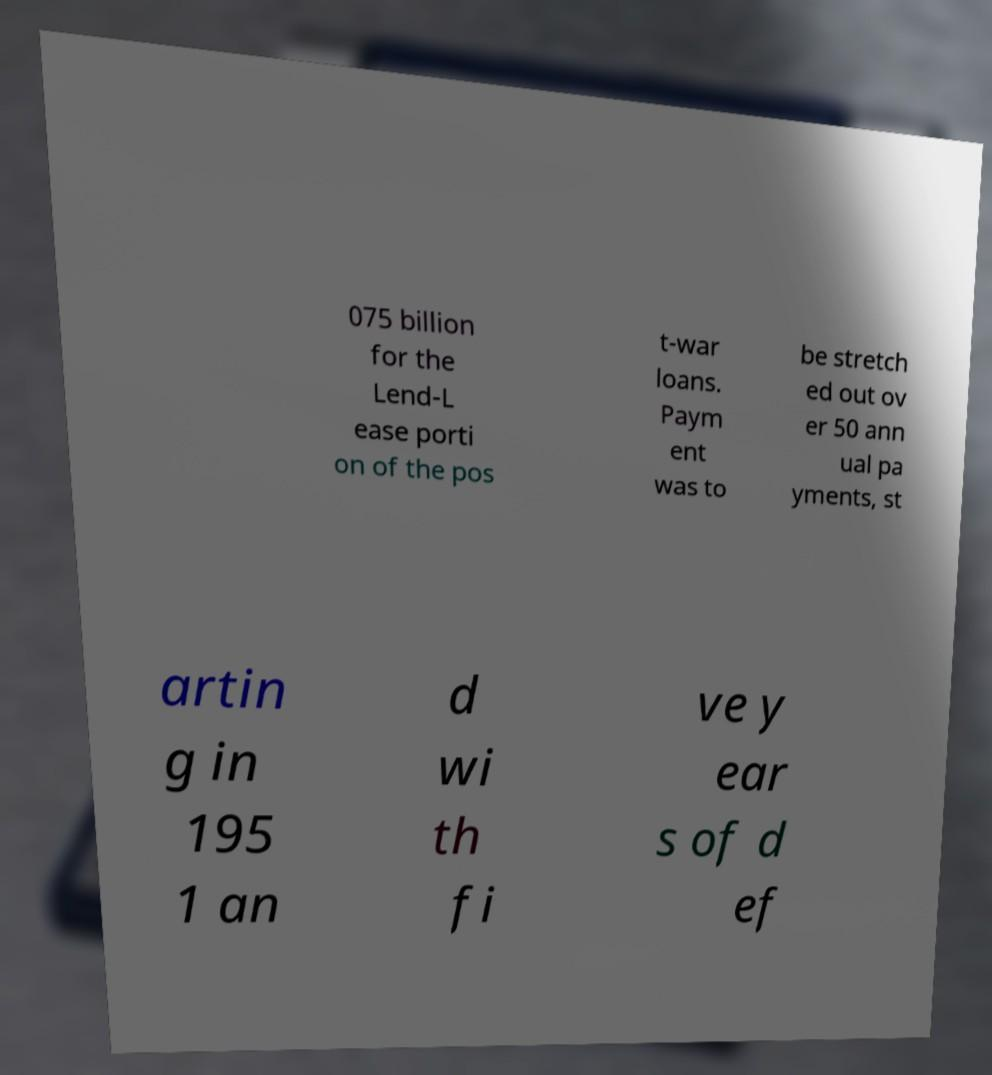Please read and relay the text visible in this image. What does it say? 075 billion for the Lend-L ease porti on of the pos t-war loans. Paym ent was to be stretch ed out ov er 50 ann ual pa yments, st artin g in 195 1 an d wi th fi ve y ear s of d ef 